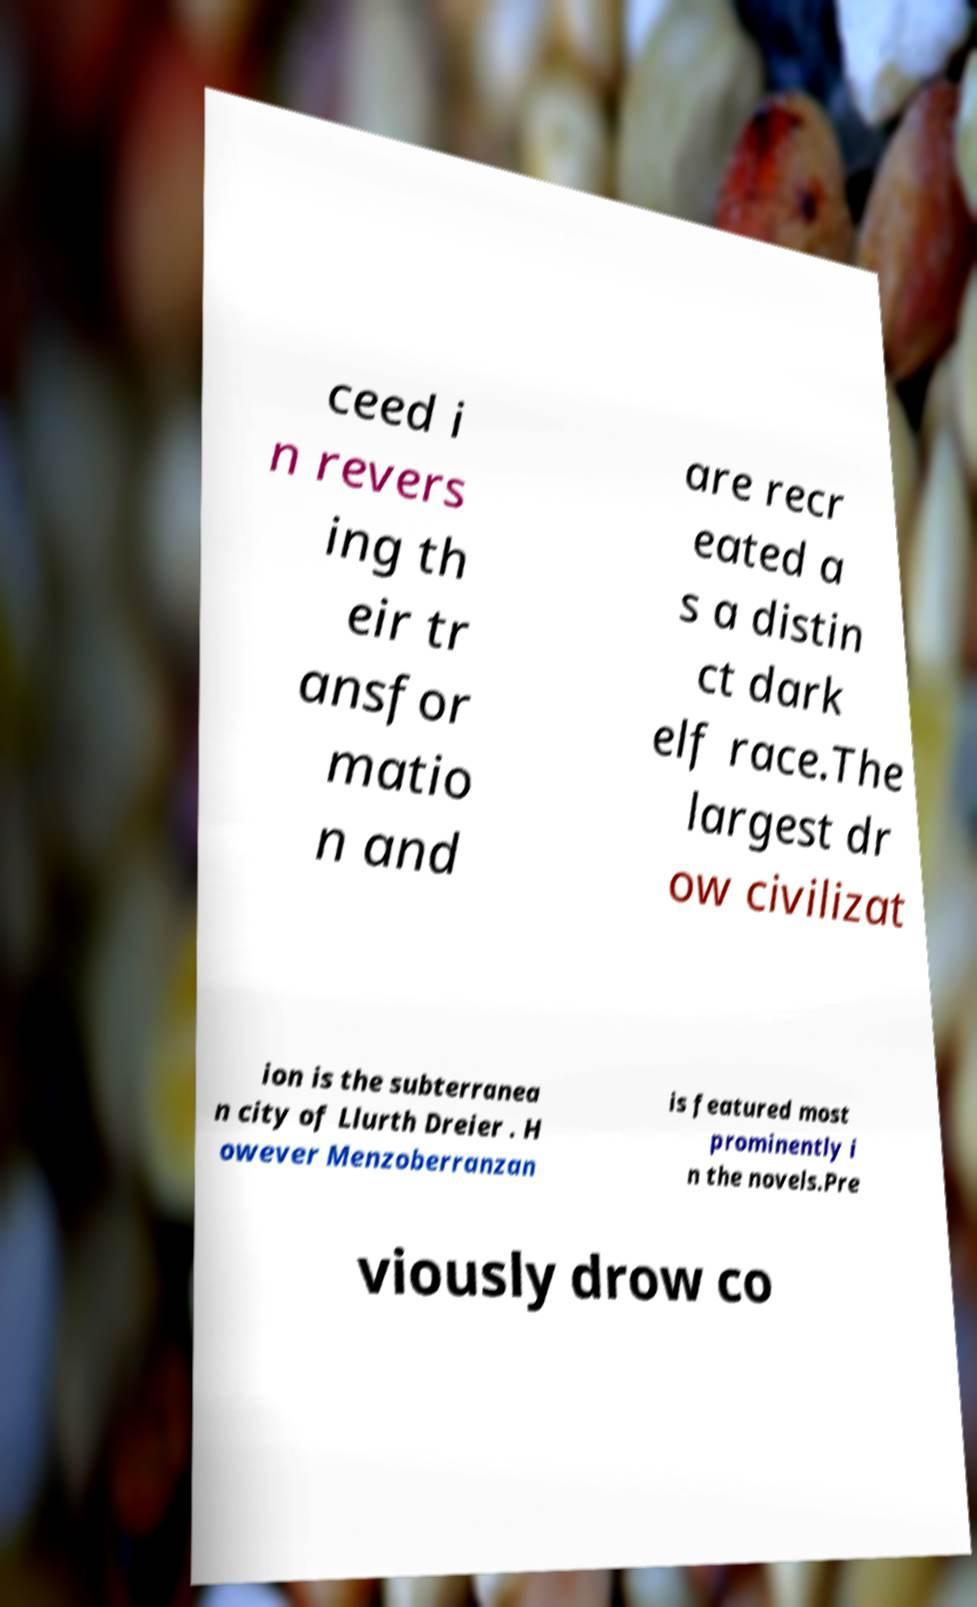For documentation purposes, I need the text within this image transcribed. Could you provide that? ceed i n revers ing th eir tr ansfor matio n and are recr eated a s a distin ct dark elf race.The largest dr ow civilizat ion is the subterranea n city of Llurth Dreier . H owever Menzoberranzan is featured most prominently i n the novels.Pre viously drow co 